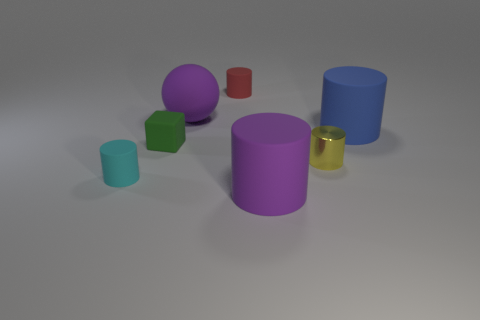Subtract all red cylinders. How many cylinders are left? 4 Subtract all red cylinders. How many cylinders are left? 4 Subtract all green cylinders. Subtract all red cubes. How many cylinders are left? 5 Add 1 small yellow cylinders. How many objects exist? 8 Subtract all cubes. How many objects are left? 6 Add 1 balls. How many balls are left? 2 Add 5 big balls. How many big balls exist? 6 Subtract 0 gray spheres. How many objects are left? 7 Subtract all small red matte objects. Subtract all green matte cubes. How many objects are left? 5 